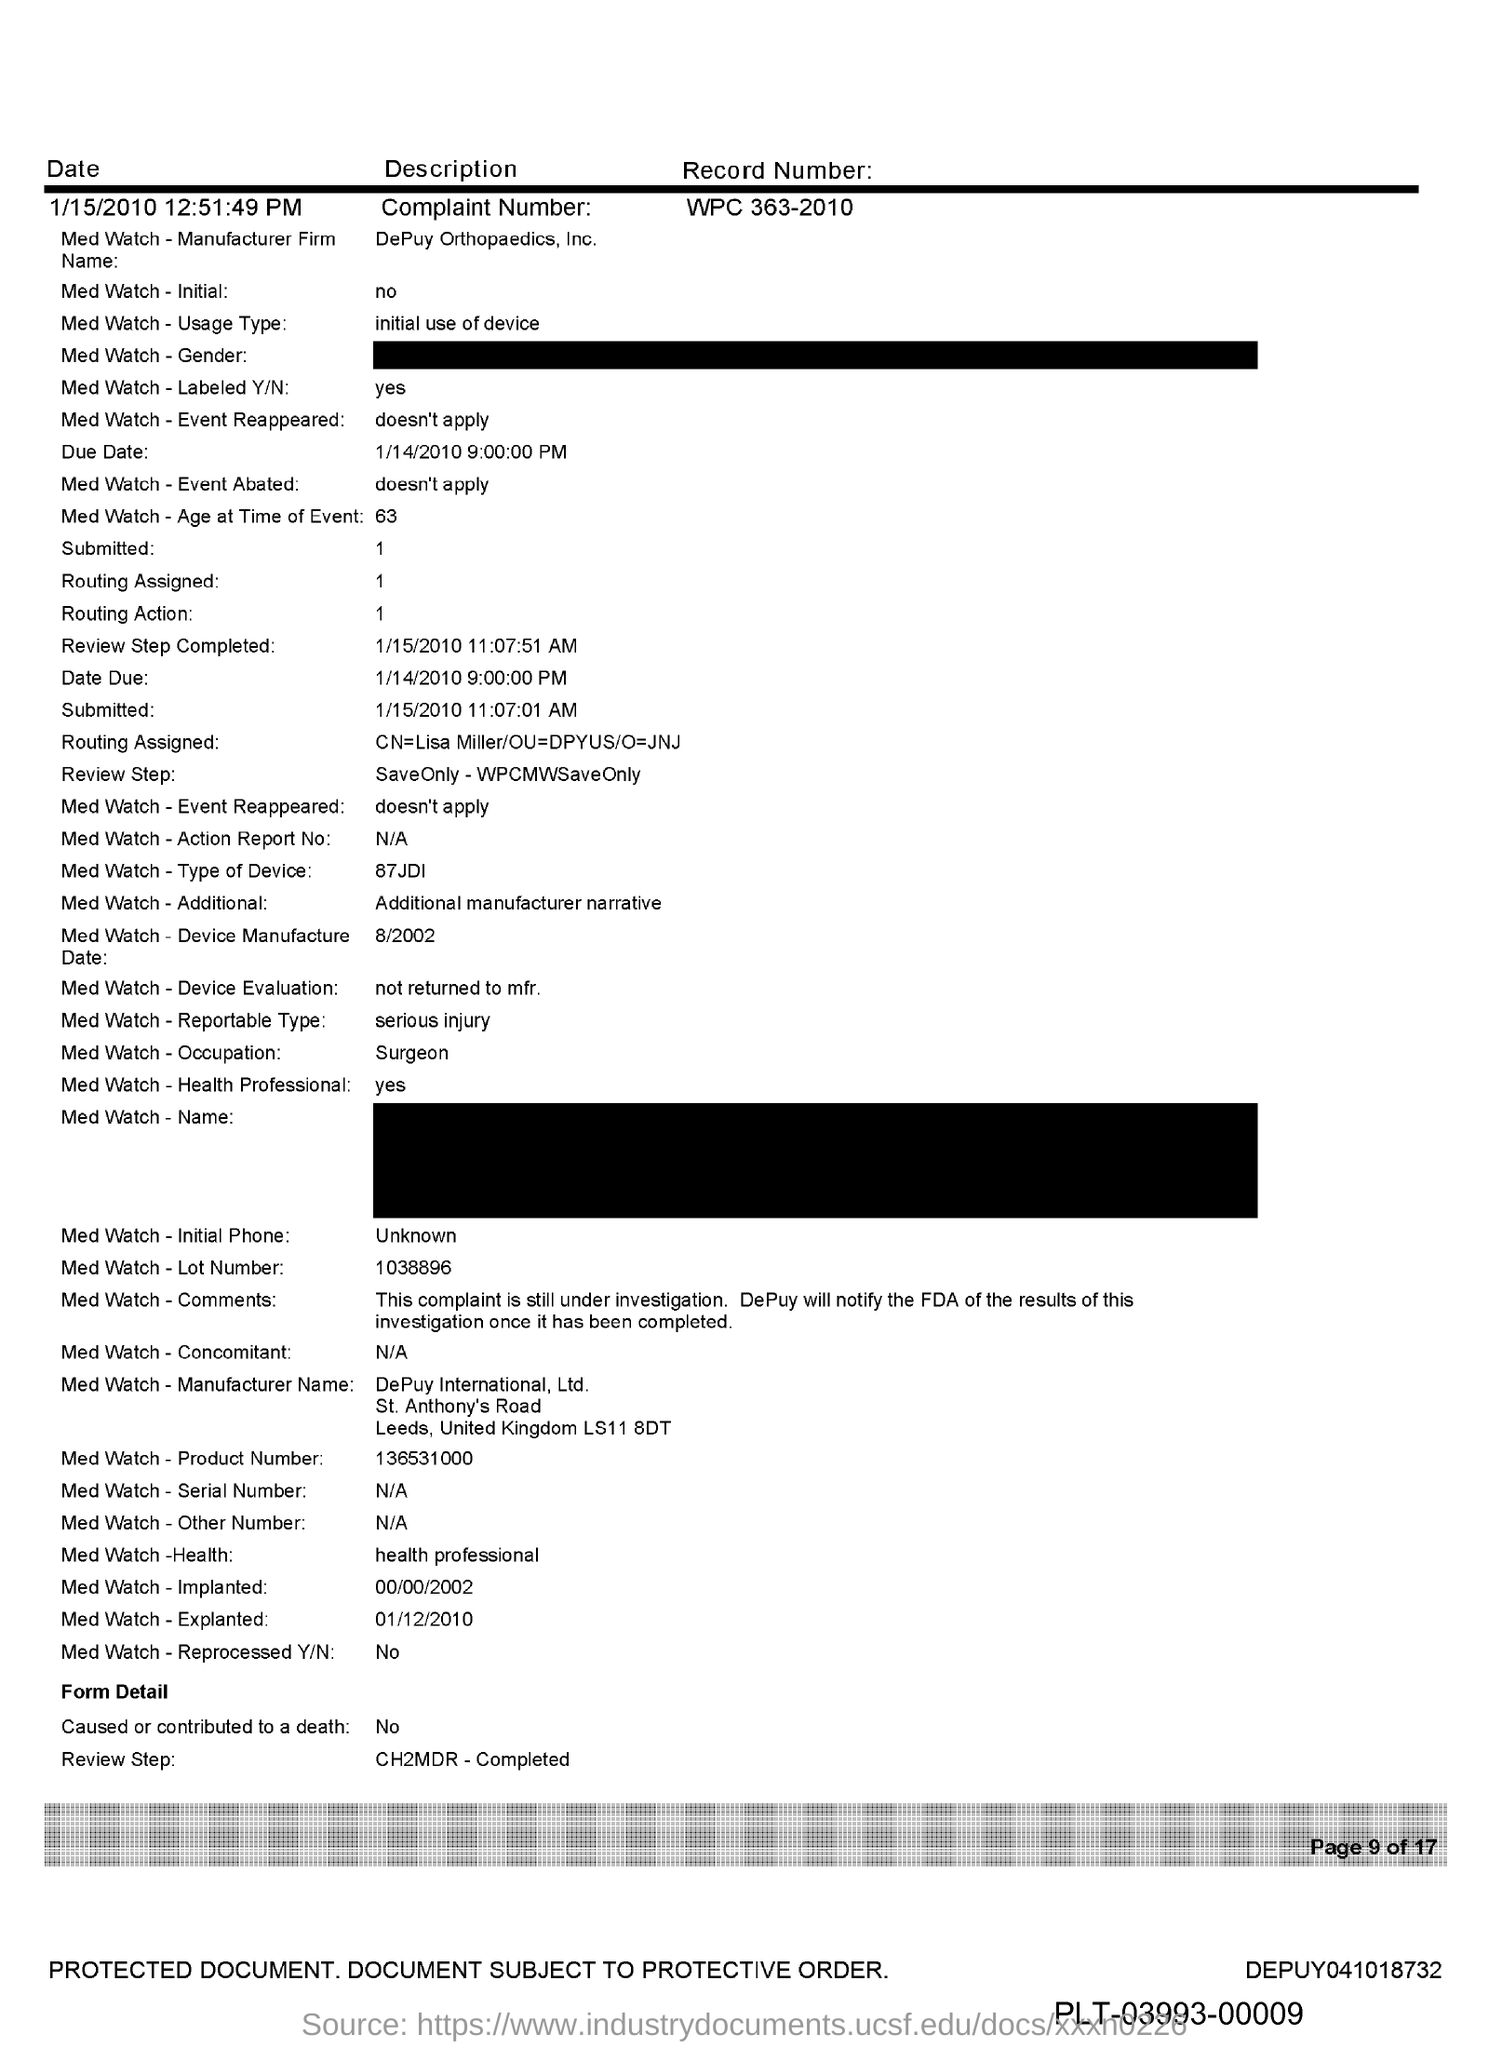What is the complaint number?
Give a very brief answer. WPC 363-2010. 